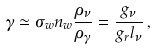<formula> <loc_0><loc_0><loc_500><loc_500>\gamma \simeq \sigma _ { w } n _ { w } \frac { \rho _ { \nu } } { \rho _ { \gamma } } = \frac { g _ { \nu } } { g _ { r } l _ { \nu } } \, ,</formula> 